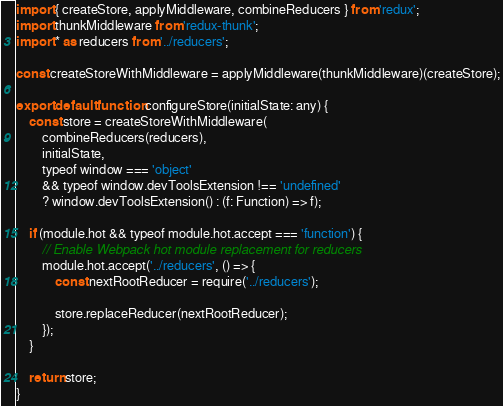Convert code to text. <code><loc_0><loc_0><loc_500><loc_500><_JavaScript_>import { createStore, applyMiddleware, combineReducers } from 'redux';
import thunkMiddleware from 'redux-thunk';
import * as reducers from '../reducers';

const createStoreWithMiddleware = applyMiddleware(thunkMiddleware)(createStore);

export default function configureStore(initialState: any) {
	const store = createStoreWithMiddleware(
		combineReducers(reducers),
		initialState,
		typeof window === 'object'
		&& typeof window.devToolsExtension !== 'undefined'
		? window.devToolsExtension() : (f: Function) => f);

	if (module.hot && typeof module.hot.accept === 'function') {
		// Enable Webpack hot module replacement for reducers
		module.hot.accept('../reducers', () => {
			const nextRootReducer = require('../reducers');

			store.replaceReducer(nextRootReducer);
		});
	}

	return store;
}
</code> 